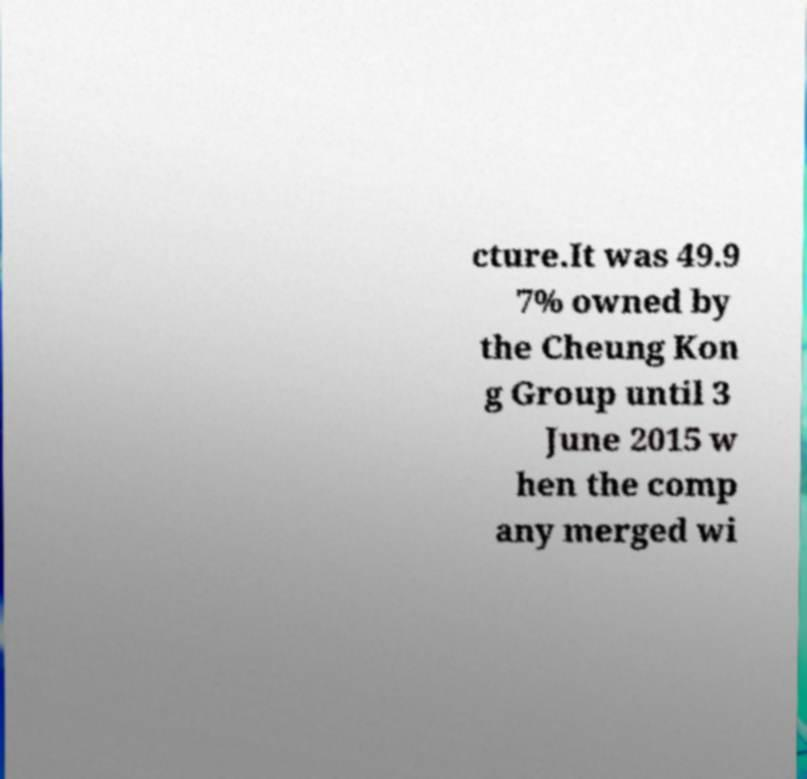Can you accurately transcribe the text from the provided image for me? cture.It was 49.9 7% owned by the Cheung Kon g Group until 3 June 2015 w hen the comp any merged wi 